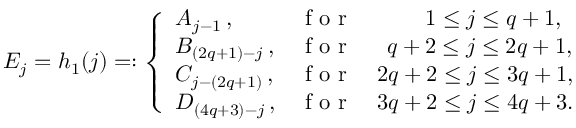<formula> <loc_0><loc_0><loc_500><loc_500>E _ { j } = h _ { 1 } ( j ) = \colon \left \{ \begin{array} { l l } { A _ { j - 1 } \, , } & { f o r \quad \, 1 \leq j \leq q + 1 , } \\ { B _ { ( 2 q + 1 ) - j } \, , } & { f o r \quad \, q + 2 \leq j \leq 2 q + 1 , } \\ { C _ { j - ( 2 q + 1 ) } \, , } & { f o r \quad 2 q + 2 \leq j \leq 3 q + 1 , } \\ { D _ { ( 4 q + 3 ) - j } \, , } & { f o r \quad 3 q + 2 \leq j \leq 4 q + 3 . } \end{array}</formula> 